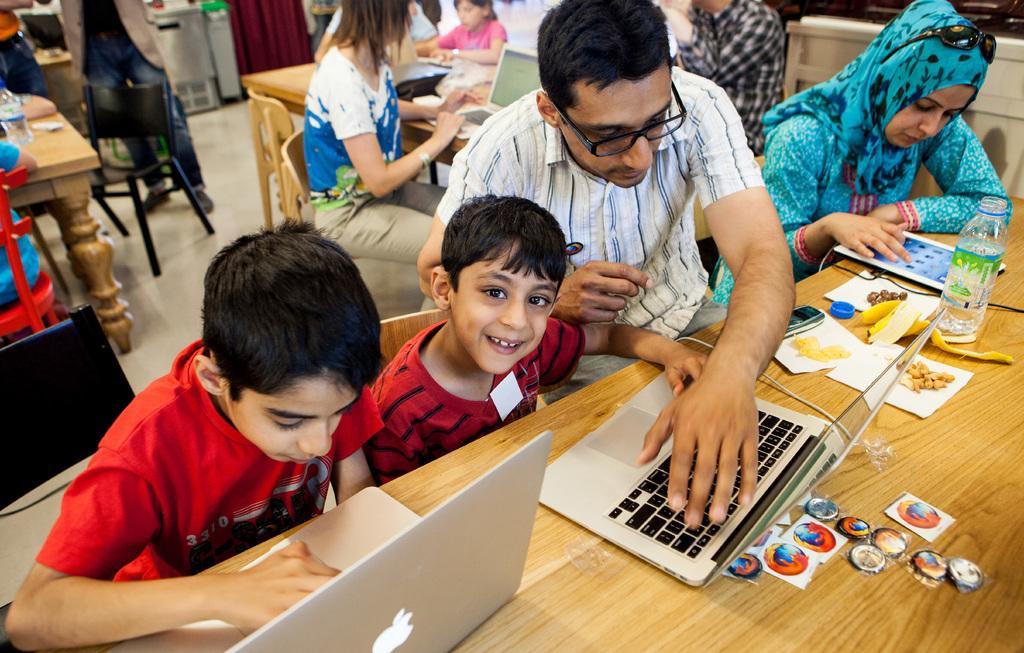In one or two sentences, can you explain what this image depicts? In this image I can see group of people sitting. The person in front wearing red color dress and working on the laptop. I can also see the other laptop, few papers, a bottle on the table and the table is in brown color. Background I can see few other people sitting and curtain in maroon color. 